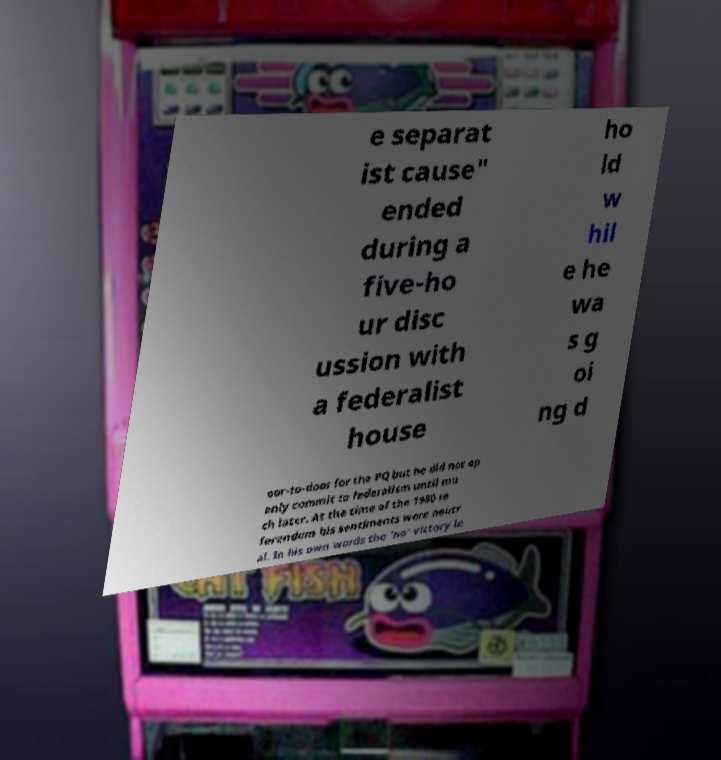Can you accurately transcribe the text from the provided image for me? e separat ist cause" ended during a five-ho ur disc ussion with a federalist house ho ld w hil e he wa s g oi ng d oor-to-door for the PQ but he did not op enly commit to federalism until mu ch later. At the time of the 1980 re ferendum his sentiments were neutr al. In his own words the 'no' victory le 